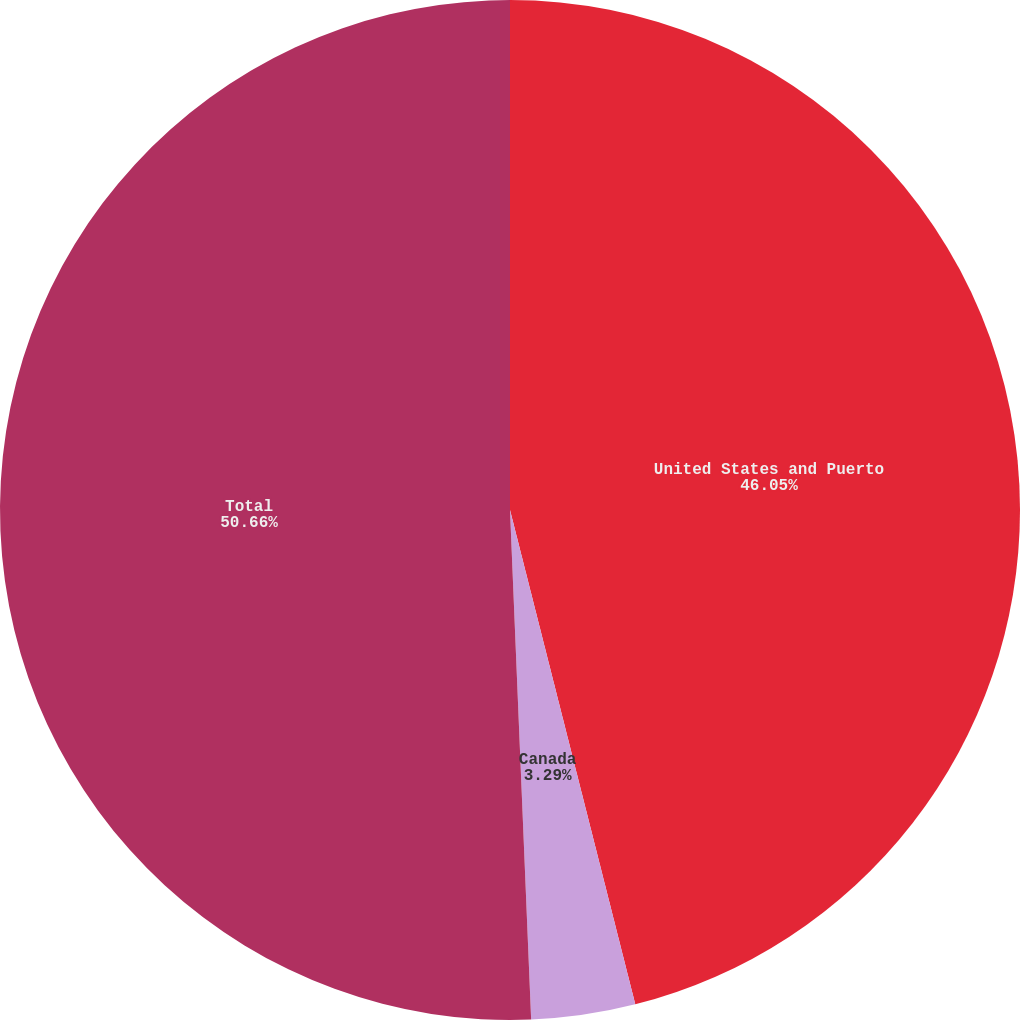Convert chart to OTSL. <chart><loc_0><loc_0><loc_500><loc_500><pie_chart><fcel>United States and Puerto<fcel>Canada<fcel>Total<nl><fcel>46.05%<fcel>3.29%<fcel>50.66%<nl></chart> 